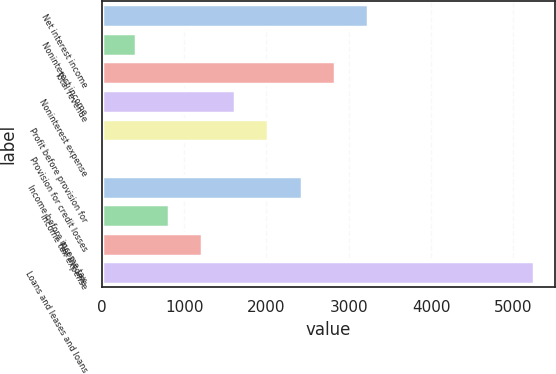Convert chart. <chart><loc_0><loc_0><loc_500><loc_500><bar_chart><fcel>Net interest income<fcel>Noninterest income<fcel>Total revenue<fcel>Noninterest expense<fcel>Profit before provision for<fcel>Provision for credit losses<fcel>Income before income tax<fcel>Income tax expense<fcel>Net income<fcel>Loans and leases and loans<nl><fcel>3233<fcel>412<fcel>2830<fcel>1621<fcel>2024<fcel>9<fcel>2427<fcel>815<fcel>1218<fcel>5248<nl></chart> 